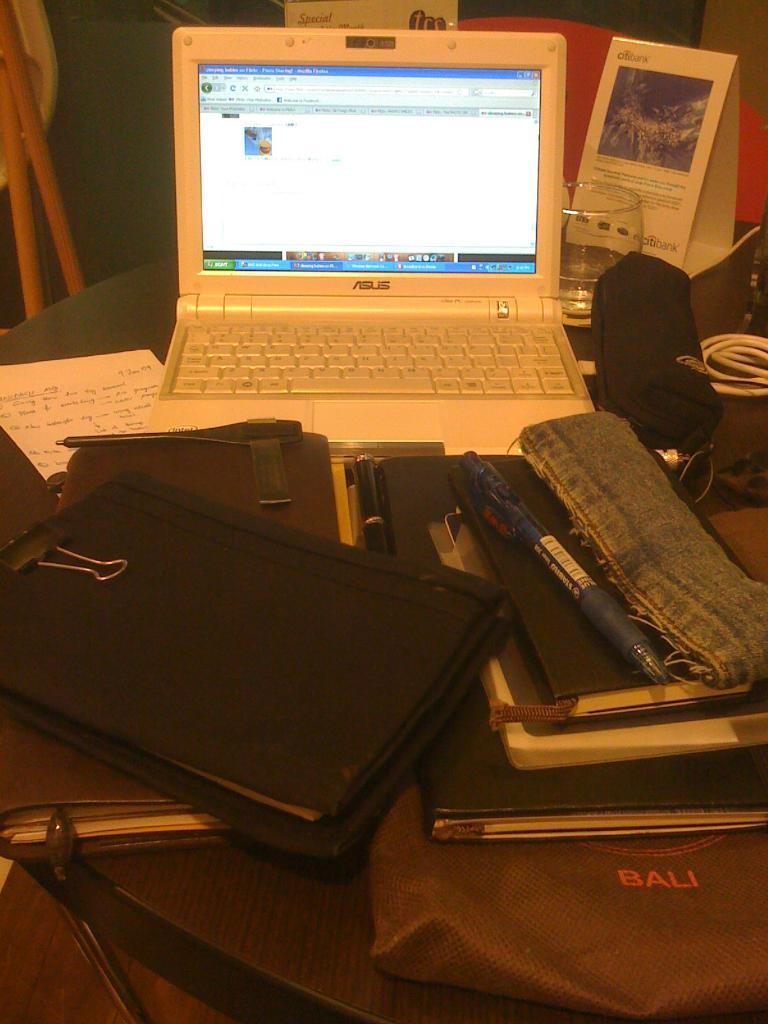<image>
Give a short and clear explanation of the subsequent image. An ASUS laptop sits open in front of several notebooks and a bag that says BALI 